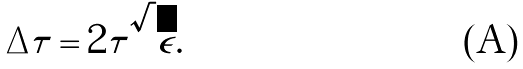Convert formula to latex. <formula><loc_0><loc_0><loc_500><loc_500>\Delta \tau = 2 \tau \sqrt { \epsilon } .</formula> 